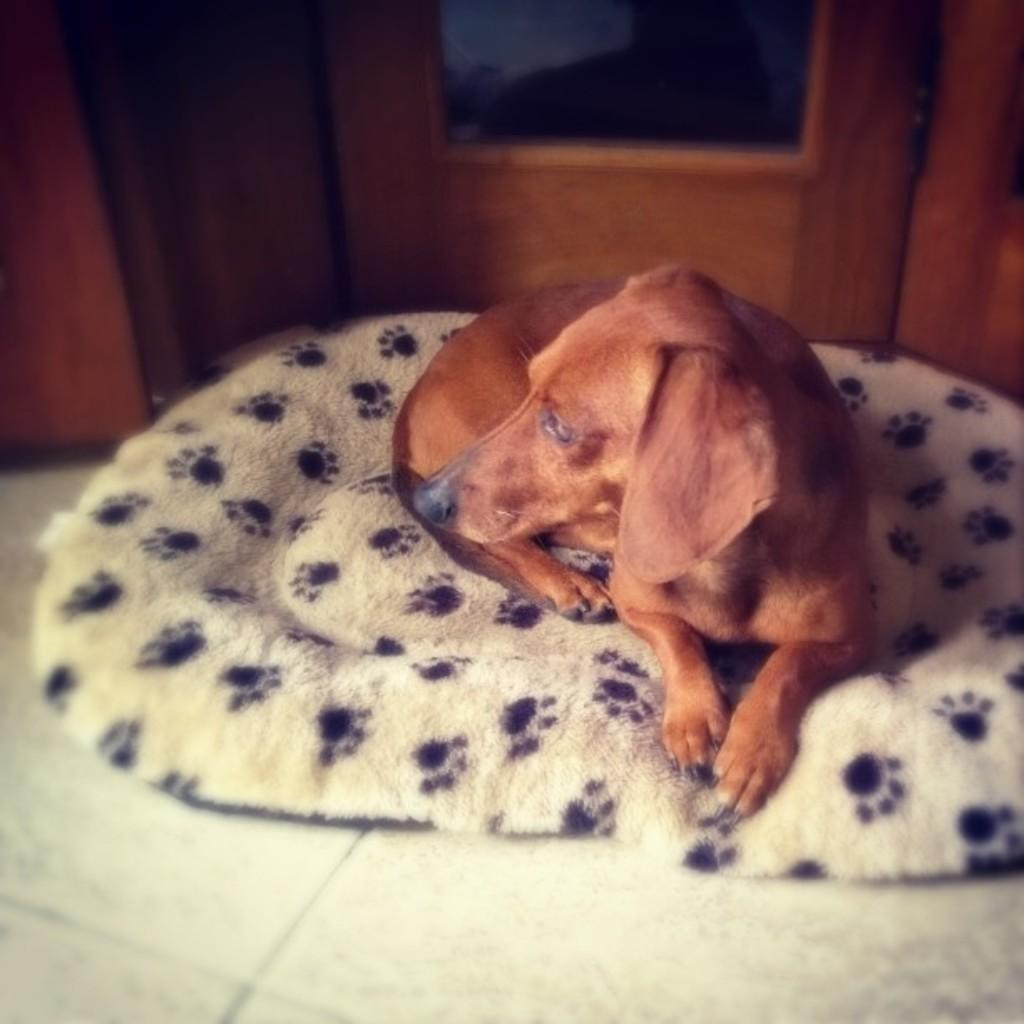What type of animal is in the image? There is a dog in the image. Where is the dog located? The dog is on a dog bed. What is the dog bed placed on? The dog bed is placed on a floor. What can be seen in the background of the image? There are wooden objects in the background of the image. What type of patch is sewn onto the dog's collar in the image? There is no patch visible on the dog's collar in the image. How many tickets can be seen in the dog's paw in the image? There are no tickets present in the image, and the dog's paw is not visible. 